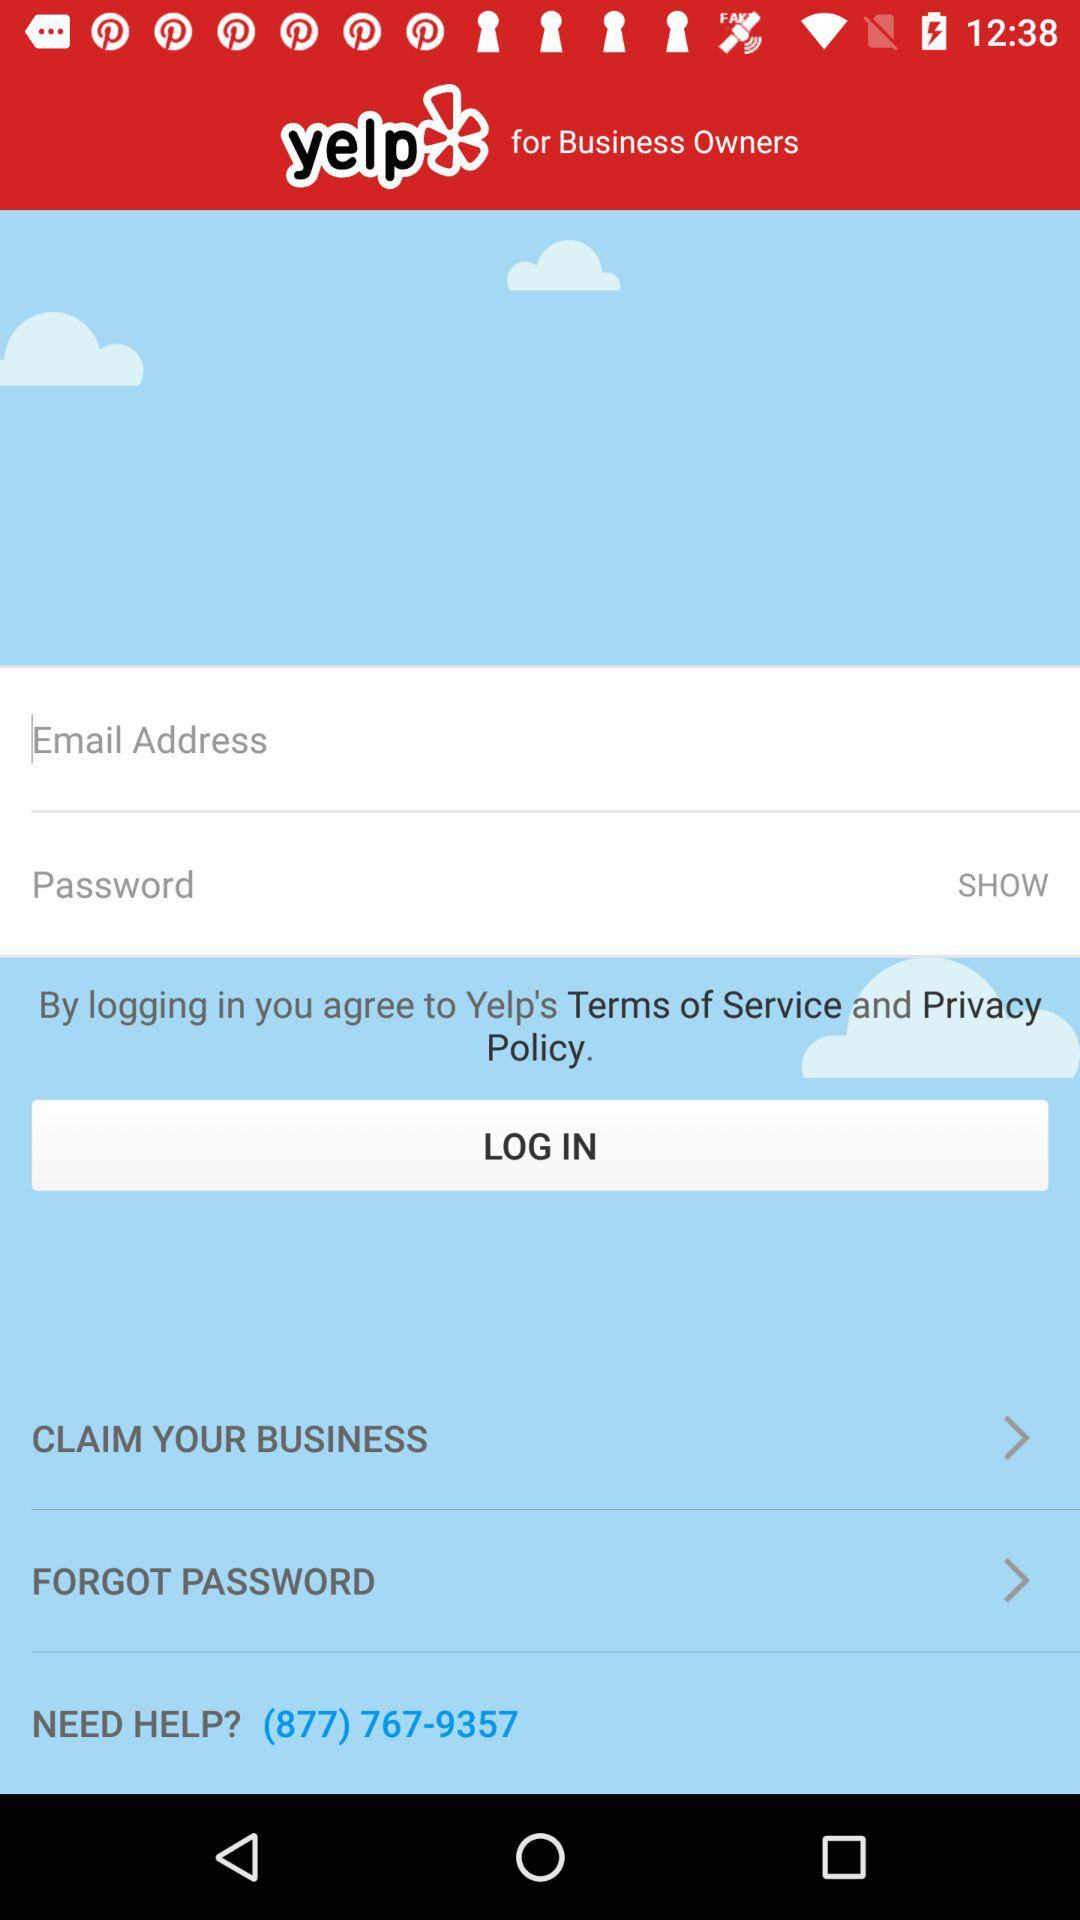What is the application name? The application name is "yelp". 